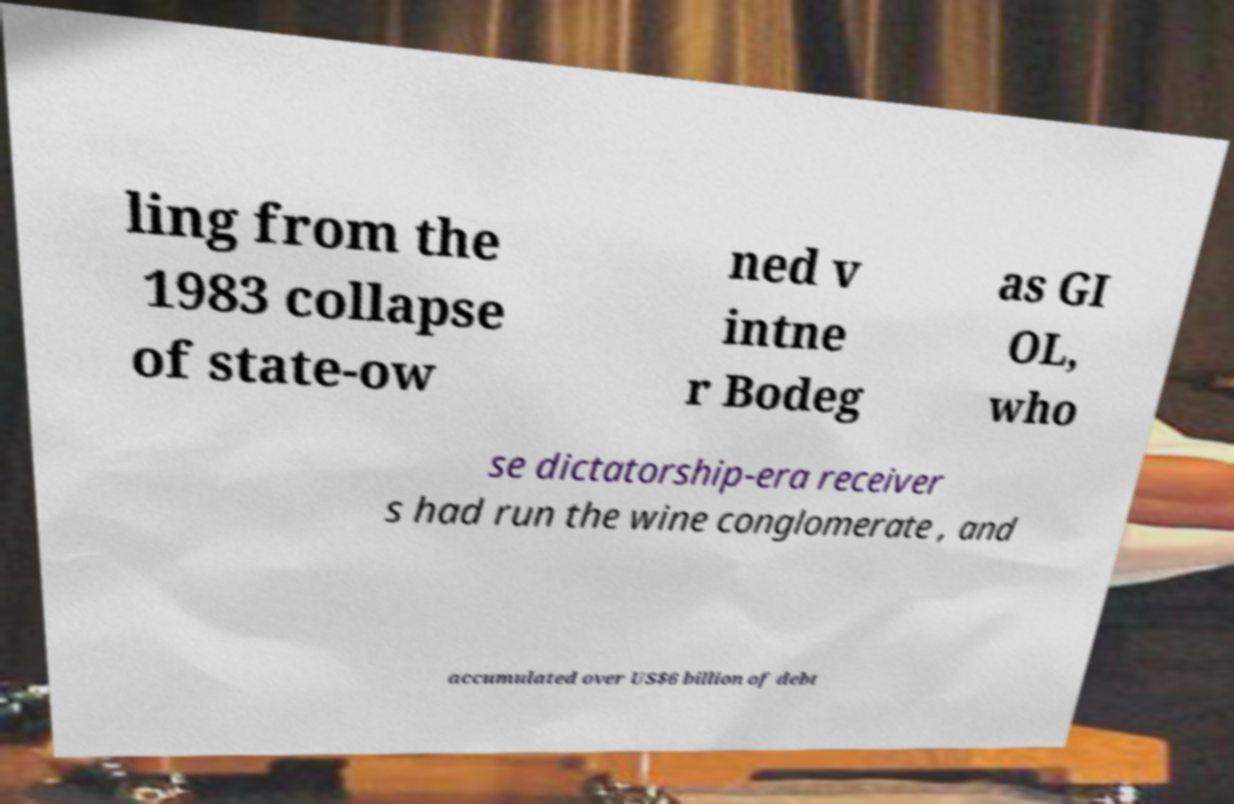For documentation purposes, I need the text within this image transcribed. Could you provide that? ling from the 1983 collapse of state-ow ned v intne r Bodeg as GI OL, who se dictatorship-era receiver s had run the wine conglomerate , and accumulated over US$6 billion of debt 